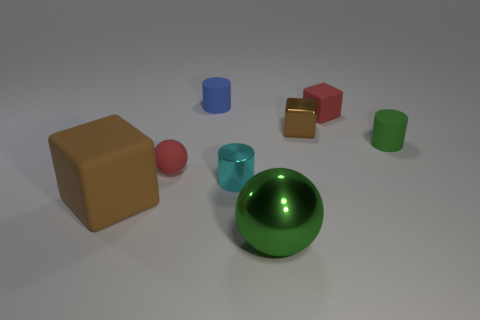Add 1 tiny cyan metallic cylinders. How many objects exist? 9 Subtract all tiny red matte cubes. How many cubes are left? 2 Subtract all cylinders. How many objects are left? 5 Add 1 blue rubber objects. How many blue rubber objects are left? 2 Add 8 tiny purple objects. How many tiny purple objects exist? 8 Subtract all red spheres. How many spheres are left? 1 Subtract 0 green blocks. How many objects are left? 8 Subtract 2 cylinders. How many cylinders are left? 1 Subtract all cyan spheres. Subtract all red blocks. How many spheres are left? 2 Subtract all cyan cylinders. How many blue balls are left? 0 